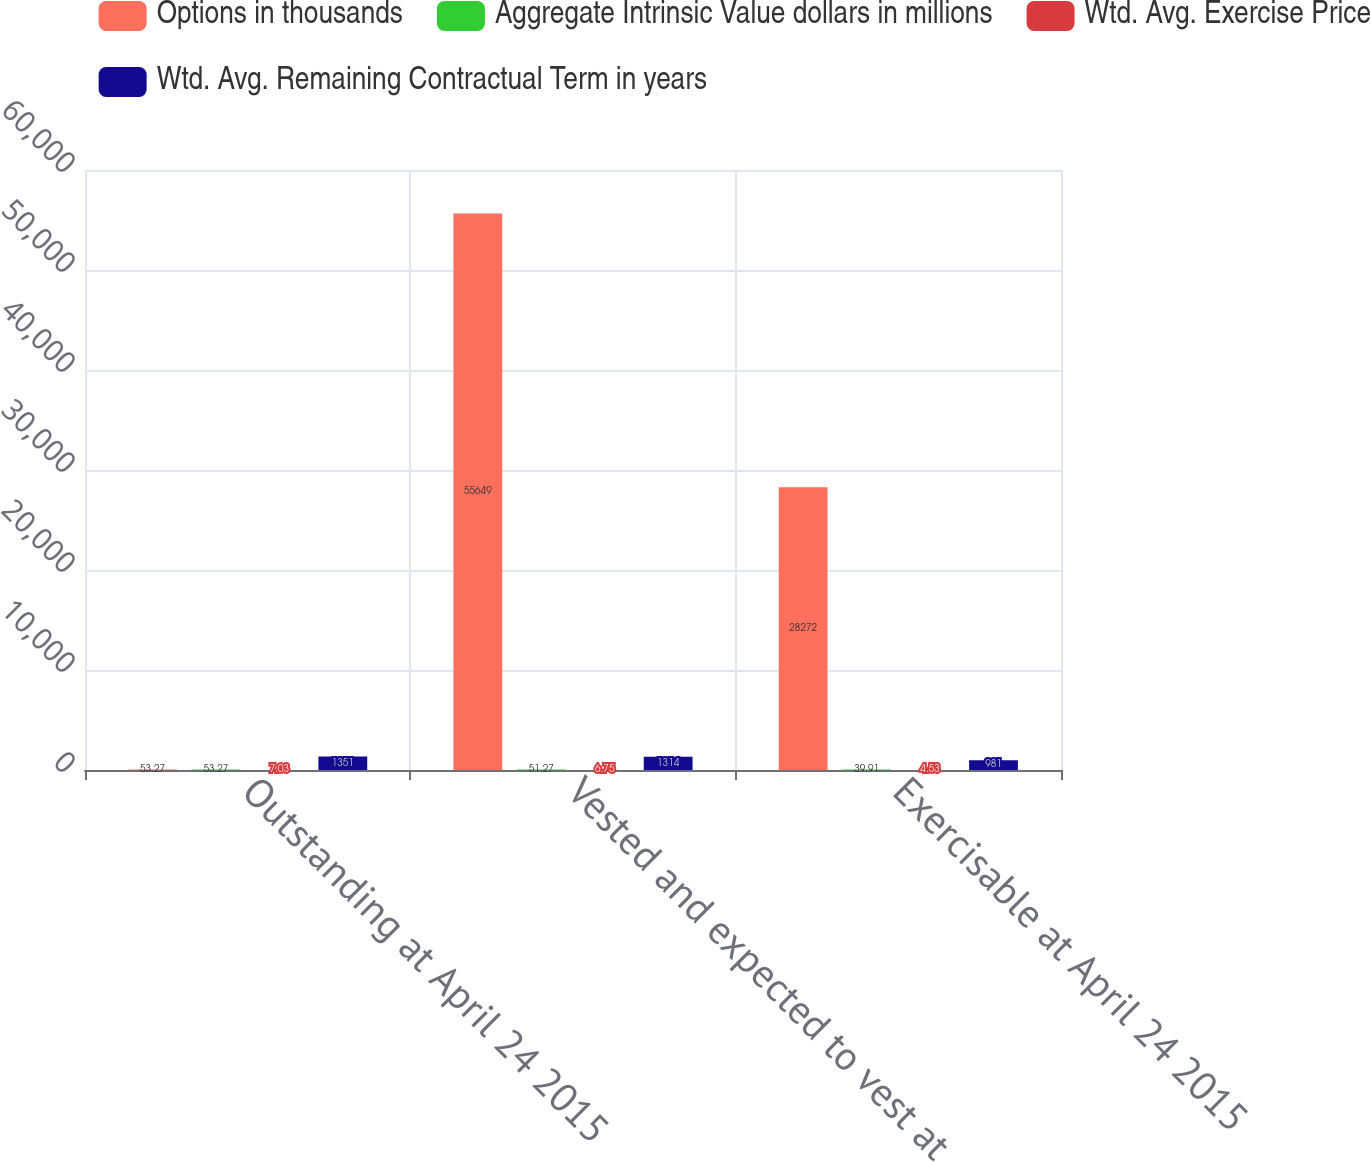<chart> <loc_0><loc_0><loc_500><loc_500><stacked_bar_chart><ecel><fcel>Outstanding at April 24 2015<fcel>Vested and expected to vest at<fcel>Exercisable at April 24 2015<nl><fcel>Options in thousands<fcel>53.27<fcel>55649<fcel>28272<nl><fcel>Aggregate Intrinsic Value dollars in millions<fcel>53.27<fcel>51.27<fcel>39.91<nl><fcel>Wtd. Avg. Exercise Price<fcel>7.03<fcel>6.75<fcel>4.53<nl><fcel>Wtd. Avg. Remaining Contractual Term in years<fcel>1351<fcel>1314<fcel>981<nl></chart> 